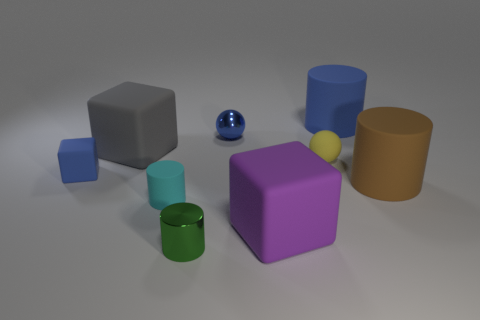There is a big gray rubber object; is it the same shape as the tiny blue object right of the tiny green cylinder?
Offer a terse response. No. What material is the small green object that is the same shape as the tiny cyan rubber object?
Your answer should be compact. Metal. What number of big objects are spheres or blue shiny spheres?
Offer a very short reply. 0. Are there fewer big gray blocks that are to the right of the tiny cyan rubber cylinder than tiny matte spheres behind the large purple thing?
Your answer should be very brief. Yes. What number of objects are large gray rubber blocks or green rubber things?
Ensure brevity in your answer.  1. How many small blue rubber cubes are behind the large blue matte cylinder?
Your answer should be compact. 0. Does the small shiny cylinder have the same color as the small rubber ball?
Your response must be concise. No. There is a small blue thing that is the same material as the big blue object; what is its shape?
Your answer should be compact. Cube. Do the tiny object that is behind the big gray matte thing and the purple matte thing have the same shape?
Provide a succinct answer. No. What number of gray objects are either large rubber cylinders or tiny spheres?
Give a very brief answer. 0. 